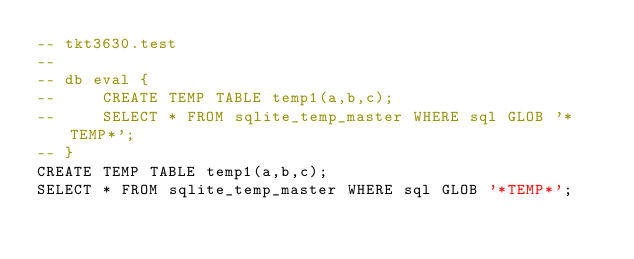Convert code to text. <code><loc_0><loc_0><loc_500><loc_500><_SQL_>-- tkt3630.test
-- 
-- db eval {
--     CREATE TEMP TABLE temp1(a,b,c);
--     SELECT * FROM sqlite_temp_master WHERE sql GLOB '*TEMP*';
-- }
CREATE TEMP TABLE temp1(a,b,c);
SELECT * FROM sqlite_temp_master WHERE sql GLOB '*TEMP*';</code> 